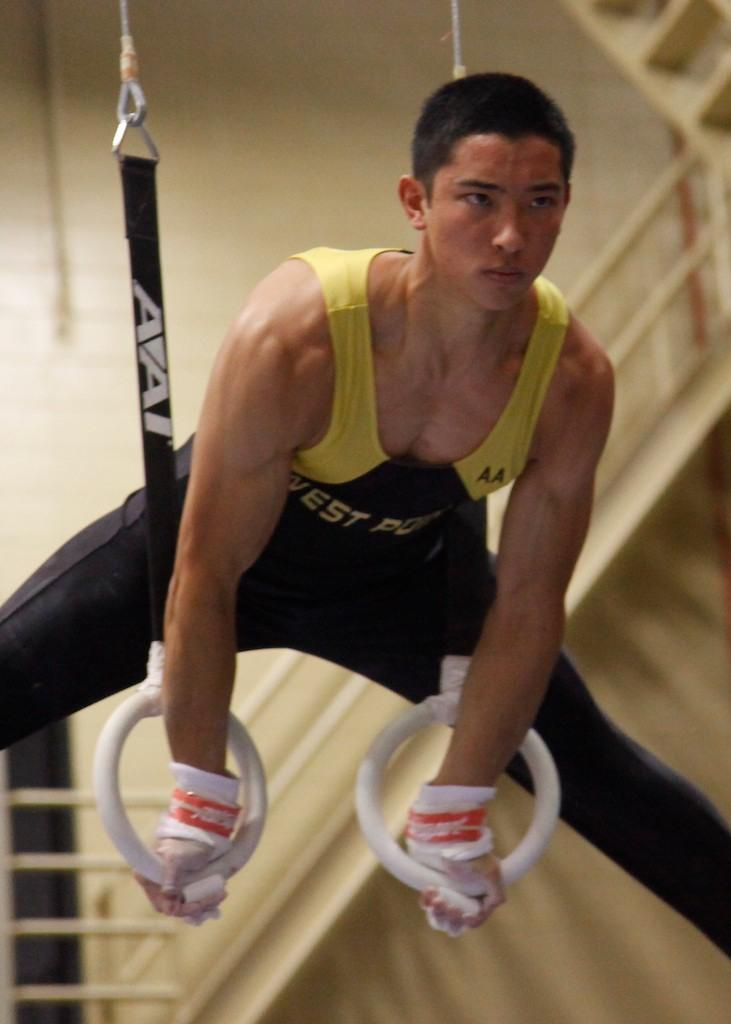<image>
Write a terse but informative summary of the picture. A gymnast from West Point balances on 2 suspended rings. 